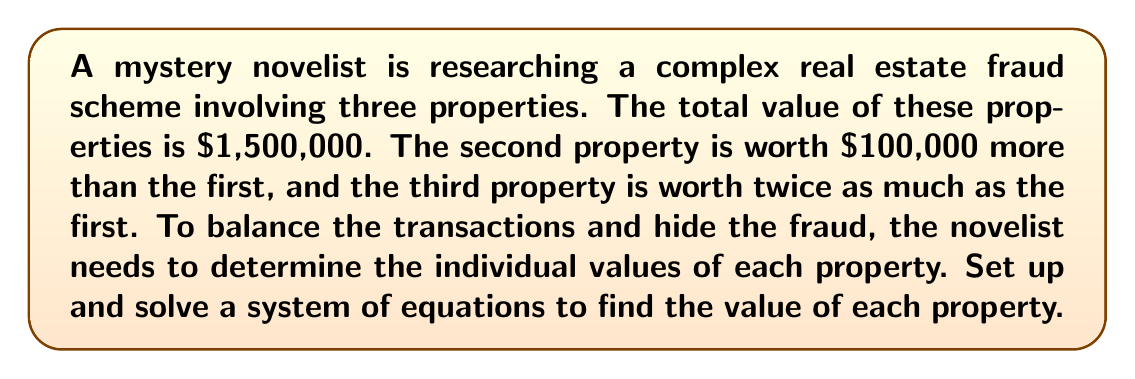Teach me how to tackle this problem. Let's approach this step-by-step:

1) Let's define our variables:
   $x$ = value of the first property
   $y$ = value of the second property
   $z$ = value of the third property

2) Now, we can set up our system of equations based on the given information:

   $$\begin{cases}
   x + y + z = 1,500,000 & \text{(total value)}\\
   y = x + 100,000 & \text{(second property)}\\
   z = 2x & \text{(third property)}
   \end{cases}$$

3) We can substitute the expressions for $y$ and $z$ into the first equation:

   $x + (x + 100,000) + 2x = 1,500,000$

4) Simplify:

   $4x + 100,000 = 1,500,000$

5) Subtract 100,000 from both sides:

   $4x = 1,400,000$

6) Divide both sides by 4:

   $x = 350,000$

7) Now that we know $x$, we can find $y$ and $z$:

   $y = x + 100,000 = 350,000 + 100,000 = 450,000$
   $z = 2x = 2(350,000) = 700,000$

8) Let's verify:
   $350,000 + 450,000 + 700,000 = 1,500,000$

Therefore, the values of the three properties are $350,000, $450,000, and $700,000.
Answer: $350,000, $450,000, $700,000 